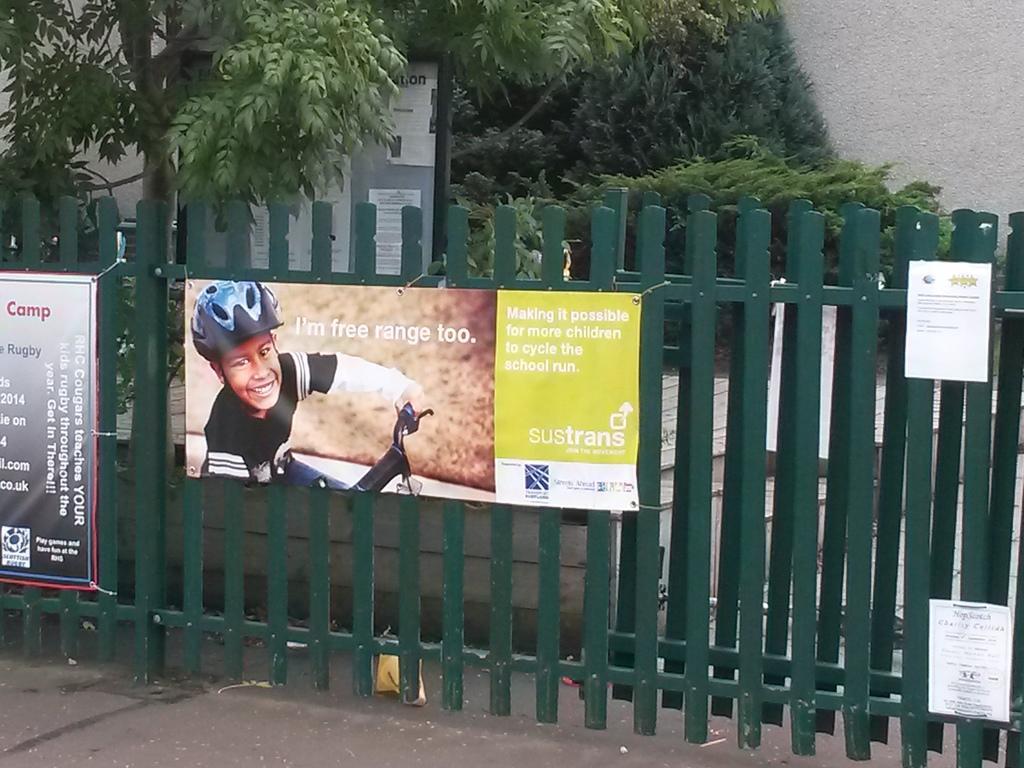How would you summarize this image in a sentence or two? In this image I see the fencing which is of green in color and I see few posts and I see something is written on them and on this poster I see a picture of a boy who is smiling. In the background I see a tree and few plants and I see few papers over here and I see the wall and I see the path over here. 